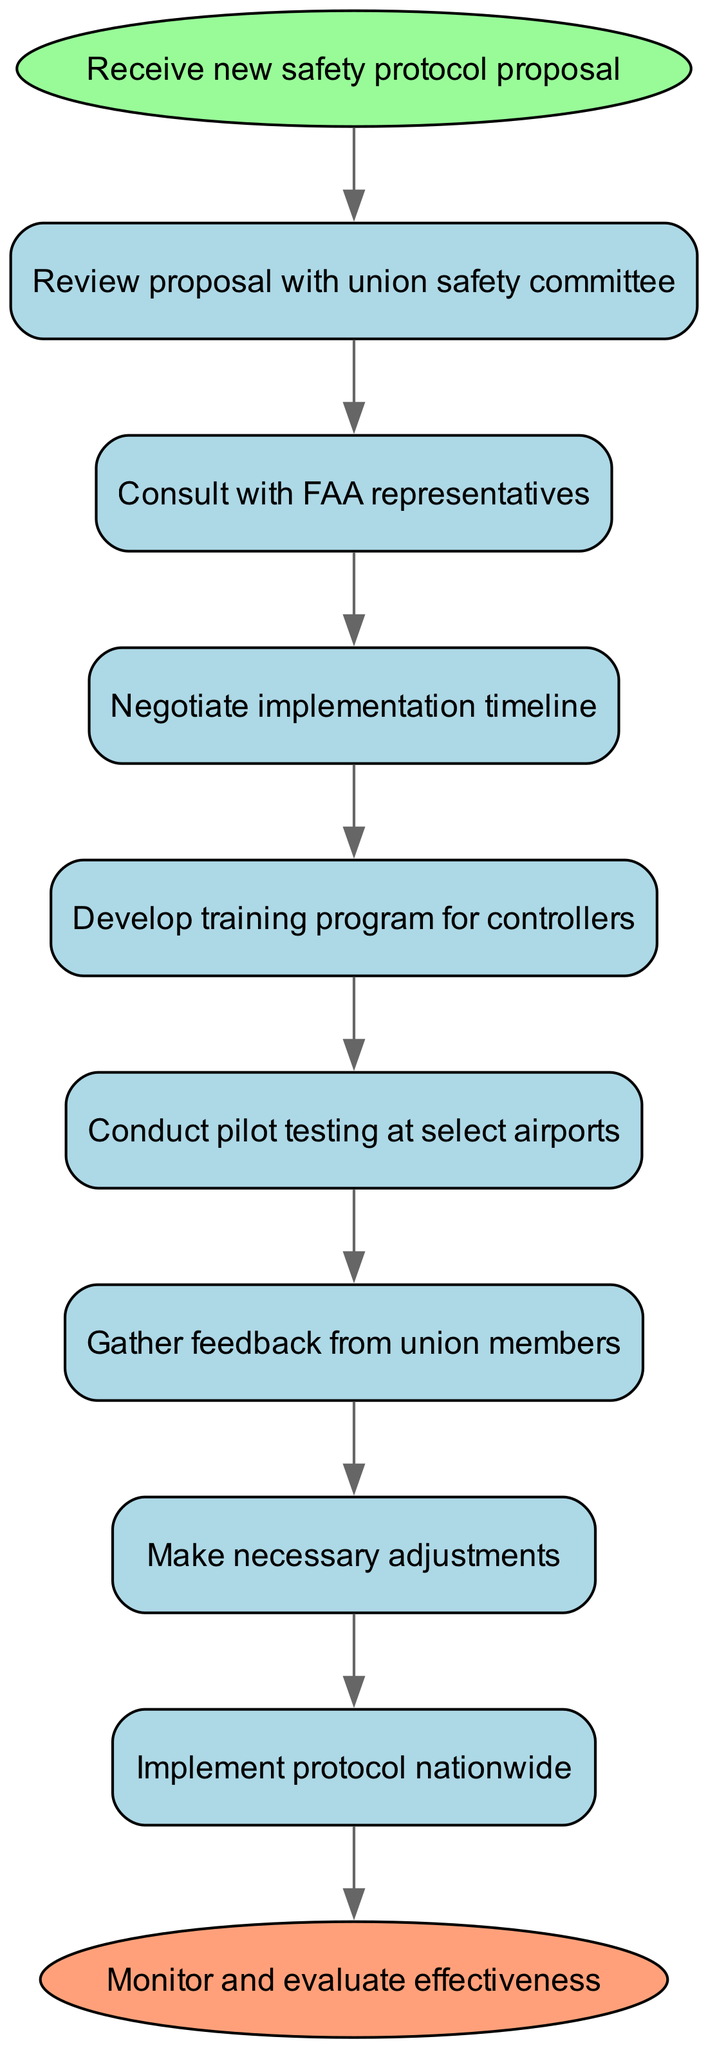What is the first step in the workflow? The first node in the diagram is labeled "Receive new safety protocol proposal," indicating it is the starting point of the workflow.
Answer: Receive new safety protocol proposal How many steps are there in total, excluding the start and end nodes? The diagram contains eight steps between the start and end nodes (from Step 1 to Step 8).
Answer: Eight What follows the consultation with FAA representatives? The edge from "Consult with FAA representatives" leads to "Negotiate implementation timeline," indicating it is the next step.
Answer: Negotiate implementation timeline After pilot testing, what is the next action to take? The flow connects "Conduct pilot testing at select airports" to "Gather feedback from union members," indicating that feedback gathering follows.
Answer: Gather feedback from union members What is the last step in the workflow? The last node before the end node is labeled "Monitor and evaluate effectiveness," which is the final step in the workflow.
Answer: Monitor and evaluate effectiveness What step comes directly after reviewing the proposal? Following "Review proposal with union safety committee," the next step is "Consult with FAA representatives," showing the flow of actions.
Answer: Consult with FAA representatives How does the workflow end? The flow diagram indicates it concludes with the "Monitor and evaluate effectiveness" node, which leads to the end node.
Answer: Monitor and evaluate effectiveness What step involves making adjustments? The node "Make necessary adjustments" directly follows "Gather feedback from union members," showing an iterative process.
Answer: Make necessary adjustments 